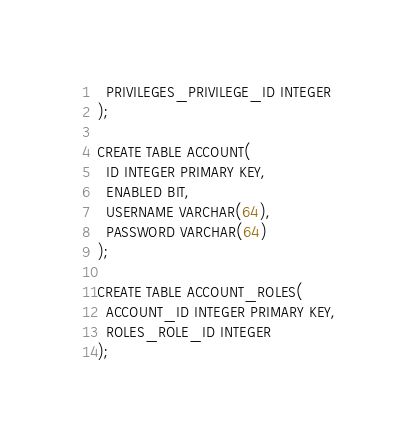Convert code to text. <code><loc_0><loc_0><loc_500><loc_500><_SQL_>  PRIVILEGES_PRIVILEGE_ID INTEGER
);

CREATE TABLE ACCOUNT(
  ID INTEGER PRIMARY KEY,
  ENABLED BIT,
  USERNAME VARCHAR(64),
  PASSWORD VARCHAR(64)
);

CREATE TABLE ACCOUNT_ROLES(
  ACCOUNT_ID INTEGER PRIMARY KEY,
  ROLES_ROLE_ID INTEGER
);</code> 